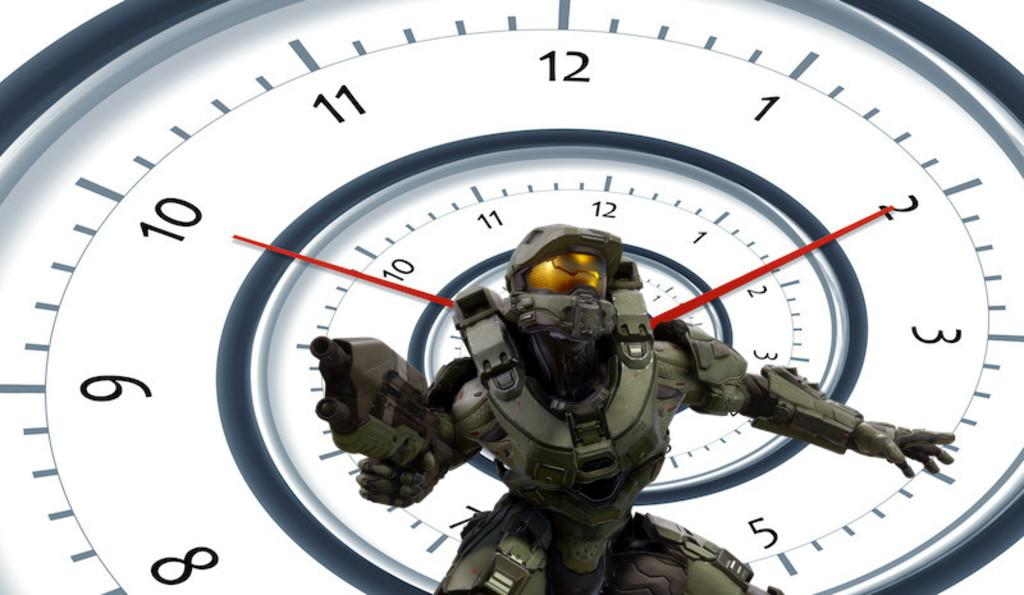Provide a one-sentence caption for the provided image. A character is posing in front of a clock which is set to 10:10. 